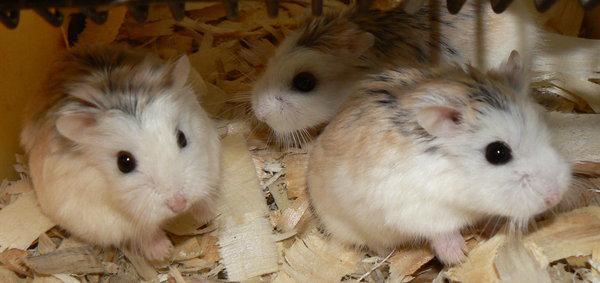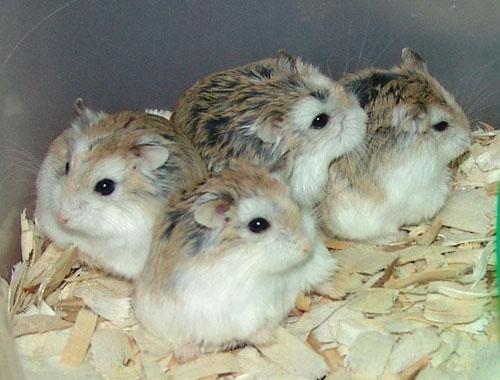The first image is the image on the left, the second image is the image on the right. Examine the images to the left and right. Is the description "The right image features exactly four hamsters." accurate? Answer yes or no. Yes. 